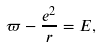<formula> <loc_0><loc_0><loc_500><loc_500>\varpi - \frac { e ^ { 2 } } r = E ,</formula> 